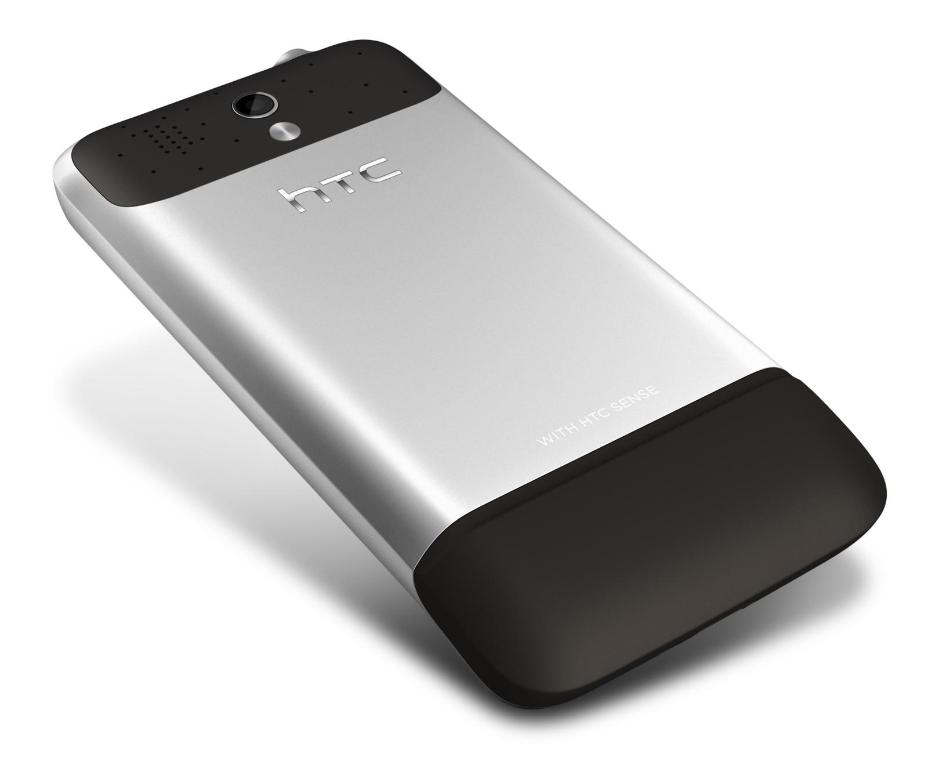Explore the aesthetic appeal of this mobile's design. The HTC phone's design is modern and minimalist, characterized by a smooth metallic finish that blends silver and black in a distinct two-tone appearance that both catches the eye and offers a tactile grip. Its simple yet sophisticated style reflects a balance of functionality and visual appeal. 